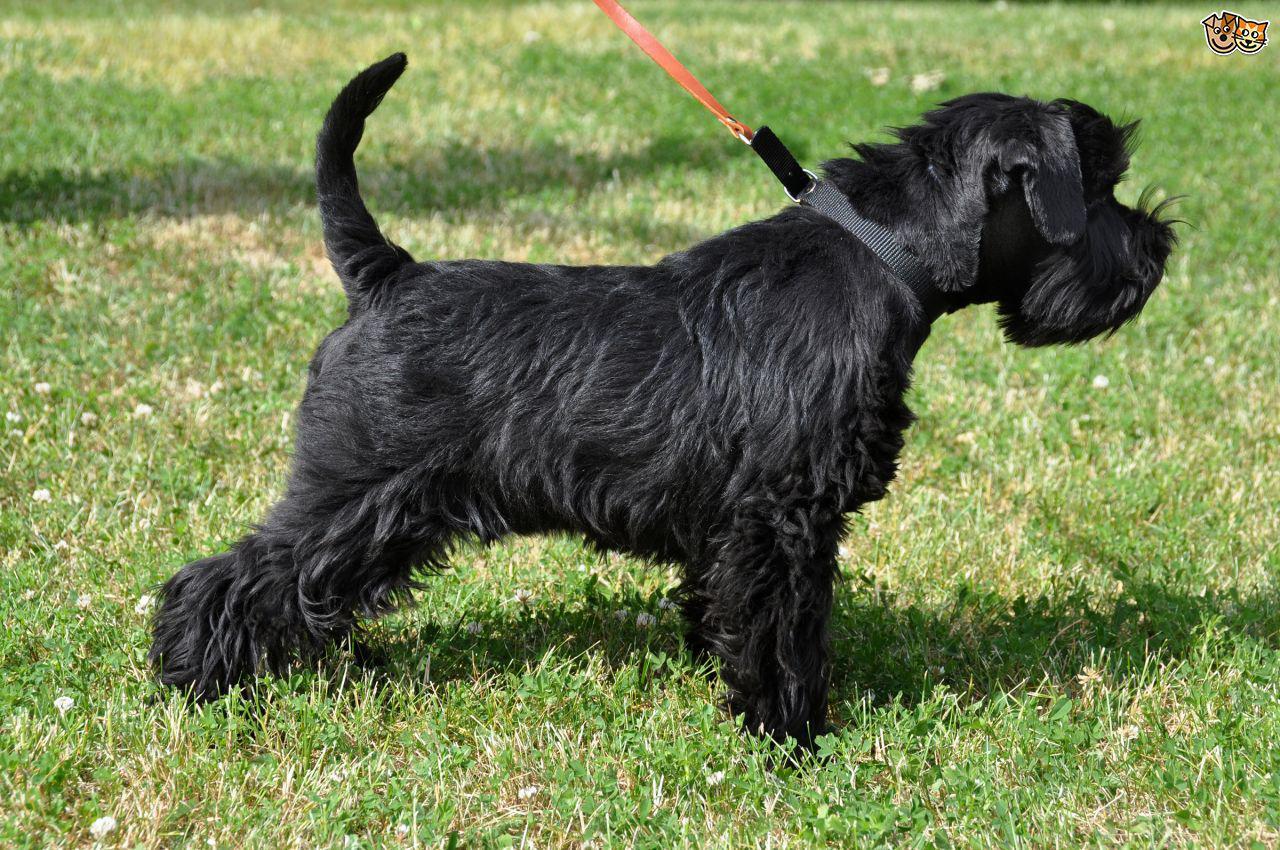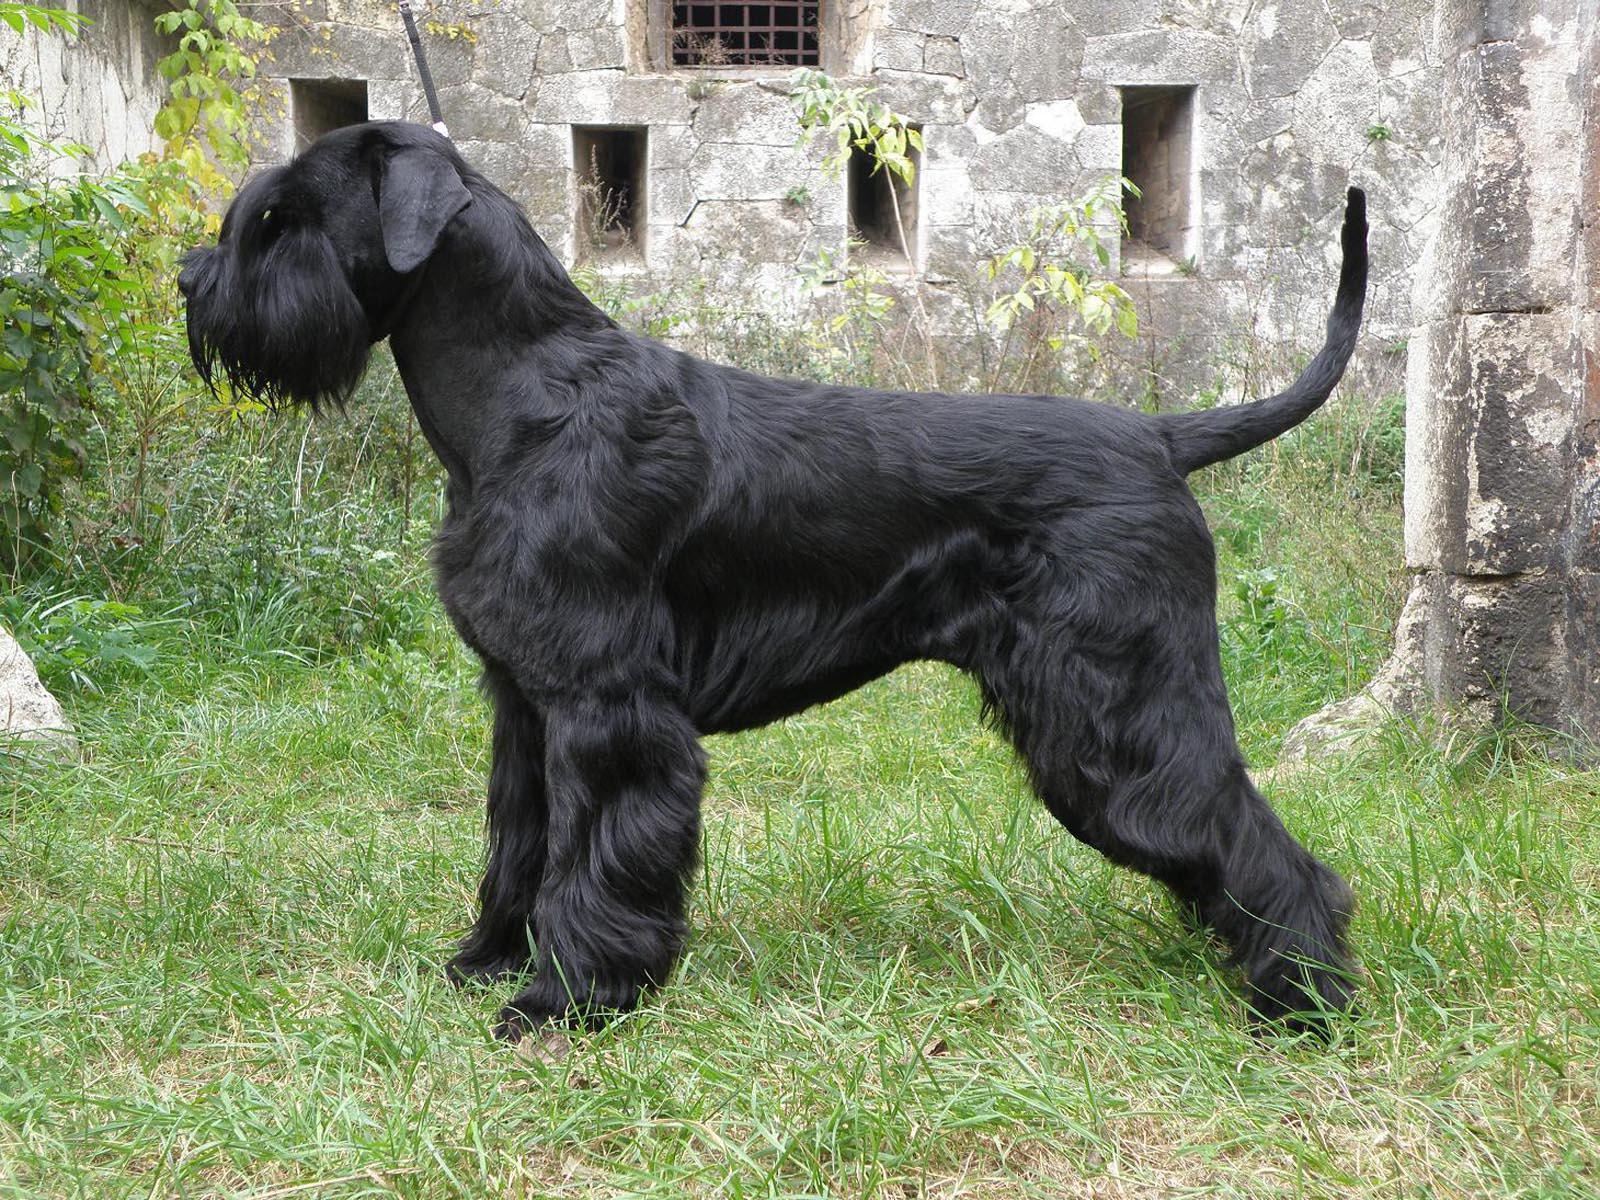The first image is the image on the left, the second image is the image on the right. For the images displayed, is the sentence "One dog has a red collar." factually correct? Answer yes or no. No. The first image is the image on the left, the second image is the image on the right. For the images displayed, is the sentence "Both dogs are standing on the grass." factually correct? Answer yes or no. Yes. The first image is the image on the left, the second image is the image on the right. Analyze the images presented: Is the assertion "Both images contain exactly one dog that is standing on grass." valid? Answer yes or no. Yes. 